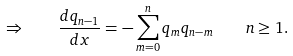<formula> <loc_0><loc_0><loc_500><loc_500>\Rightarrow \quad \frac { d q _ { n - 1 } } { d x } = - \sum _ { m = 0 } ^ { n } q _ { m } q _ { n - m } \quad n \geq 1 .</formula> 